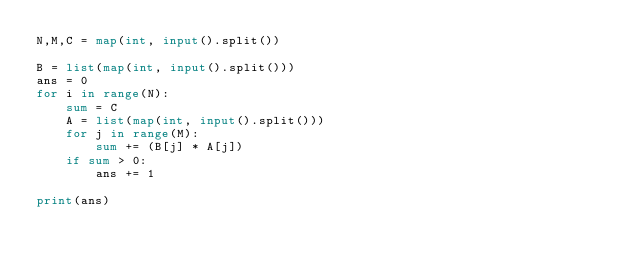<code> <loc_0><loc_0><loc_500><loc_500><_Python_>N,M,C = map(int, input().split())

B = list(map(int, input().split()))
ans = 0
for i in range(N):
    sum = C
    A = list(map(int, input().split()))
    for j in range(M):
        sum += (B[j] * A[j])
    if sum > 0:
        ans += 1

print(ans)</code> 